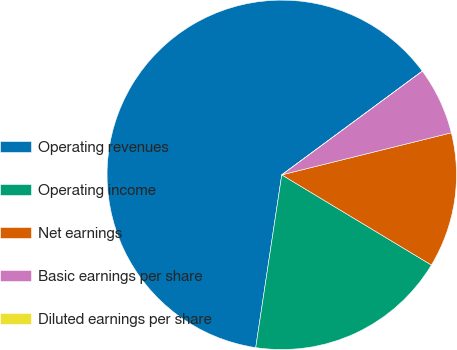<chart> <loc_0><loc_0><loc_500><loc_500><pie_chart><fcel>Operating revenues<fcel>Operating income<fcel>Net earnings<fcel>Basic earnings per share<fcel>Diluted earnings per share<nl><fcel>62.5%<fcel>18.75%<fcel>12.5%<fcel>6.25%<fcel>0.0%<nl></chart> 